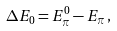<formula> <loc_0><loc_0><loc_500><loc_500>\Delta E _ { 0 } = E _ { \pi } ^ { 0 } - E _ { \pi } \, ,</formula> 